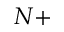<formula> <loc_0><loc_0><loc_500><loc_500>N +</formula> 